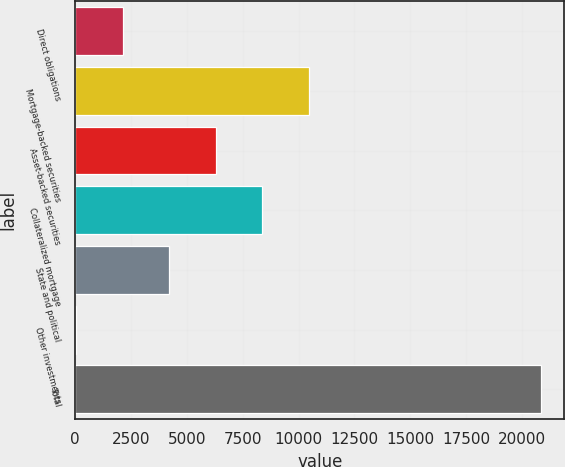Convert chart to OTSL. <chart><loc_0><loc_0><loc_500><loc_500><bar_chart><fcel>Direct obligations<fcel>Mortgage-backed securities<fcel>Asset-backed securities<fcel>Collateralized mortgage<fcel>State and political<fcel>Other investments<fcel>Total<nl><fcel>2125.1<fcel>10449.5<fcel>6287.3<fcel>8368.4<fcel>4206.2<fcel>44<fcel>20855<nl></chart> 